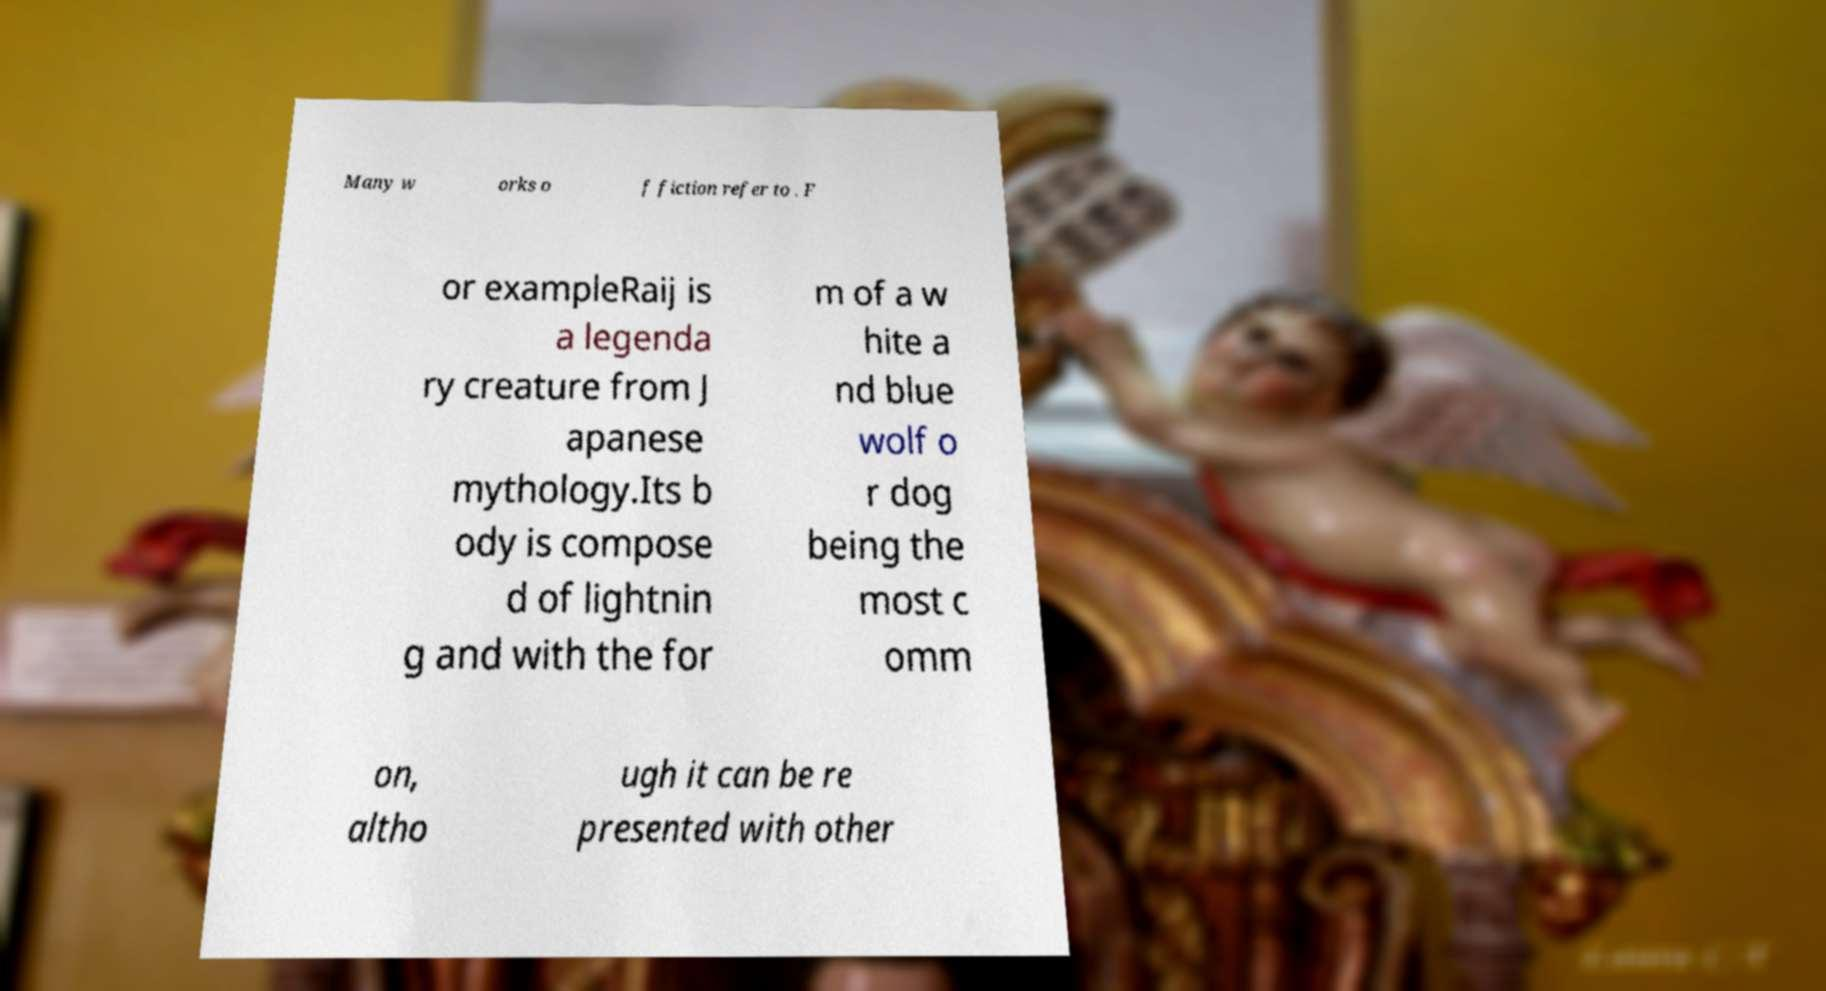Please read and relay the text visible in this image. What does it say? Many w orks o f fiction refer to . F or exampleRaij is a legenda ry creature from J apanese mythology.Its b ody is compose d of lightnin g and with the for m of a w hite a nd blue wolf o r dog being the most c omm on, altho ugh it can be re presented with other 